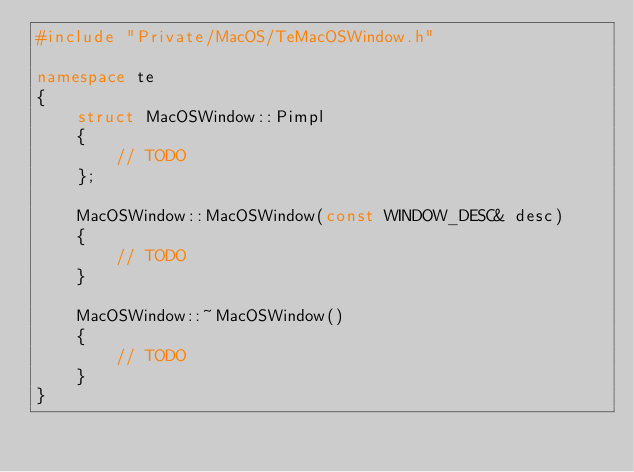Convert code to text. <code><loc_0><loc_0><loc_500><loc_500><_C++_>#include "Private/MacOS/TeMacOSWindow.h"

namespace te
{
    struct MacOSWindow::Pimpl
    {
        // TODO
    };

    MacOSWindow::MacOSWindow(const WINDOW_DESC& desc)
    {
        // TODO
    }

    MacOSWindow::~MacOSWindow()
    {
        // TODO
    }
}</code> 